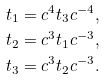Convert formula to latex. <formula><loc_0><loc_0><loc_500><loc_500>t _ { 1 } & = c ^ { 4 } t _ { 3 } c ^ { - 4 } , \\ t _ { 2 } & = c ^ { 3 } t _ { 1 } c ^ { - 3 } , \\ t _ { 3 } & = c ^ { 3 } t _ { 2 } c ^ { - 3 } .</formula> 